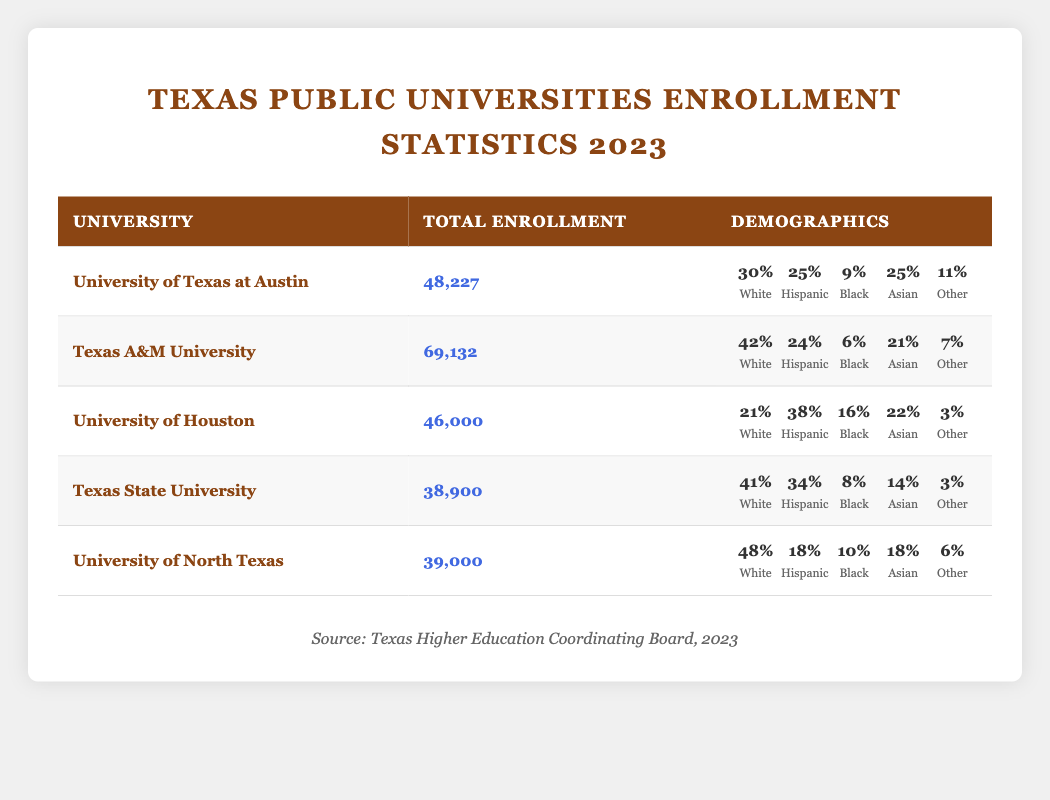What is the total enrollment at the University of Houston? The table lists the total enrollment for the University of Houston as 46,000 students.
Answer: 46,000 Which university has the highest percentage of Hispanic students? By comparing the Hispanic percentages across the universities, the University of Houston has the highest at 38%.
Answer: University of Houston What is the total percentage of Asian and Black students at Texas A&M University? The percentage of Asian students at Texas A&M is 21%, and Black students is 6%. Combining these gives 21% + 6% = 27%.
Answer: 27% Is the percentage of White students at Texas State University greater than that at the University of Houston? The percentage of White students at Texas State University is 41%, while at the University of Houston, it is 21%. Therefore, 41% > 21% is true.
Answer: Yes What is the total enrollment for all universities listed in the table? To find the total enrollment, add the enrollment numbers: 48,227 + 69,132 + 46,000 + 38,900 + 39,000 = 241,259.
Answer: 241,259 Which university has the lowest total enrollment, and what is that number? Looking at the total enrollment figures, Texas State University has the lowest number at 38,900.
Answer: Texas State University, 38,900 What is the average percentage of Black students across all universities? Adding the Black percentages gives 9% + 6% + 16% + 8% + 10% = 49%. Dividing by the number of universities (5), the average is 49% / 5 = 9.8%.
Answer: 9.8% Which university has the highest total enrollment and what is the percentage of students classified as "Other"? Texas A&M University has the highest total enrollment at 69,132, and the percentage of students classified as "Other" is 7%.
Answer: Texas A&M University, 7% What percentage of students are 'Other' at the University of North Texas? The table shows that 6% of the students at the University of North Texas fall under the 'Other' demographic.
Answer: 6% 